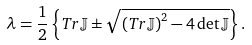Convert formula to latex. <formula><loc_0><loc_0><loc_500><loc_500>\lambda = \frac { 1 } { 2 } \left \{ T r \mathbb { J } \pm \sqrt { \left ( T r \mathbb { J } \right ) ^ { 2 } - 4 \det \mathbb { J } } \right \} .</formula> 